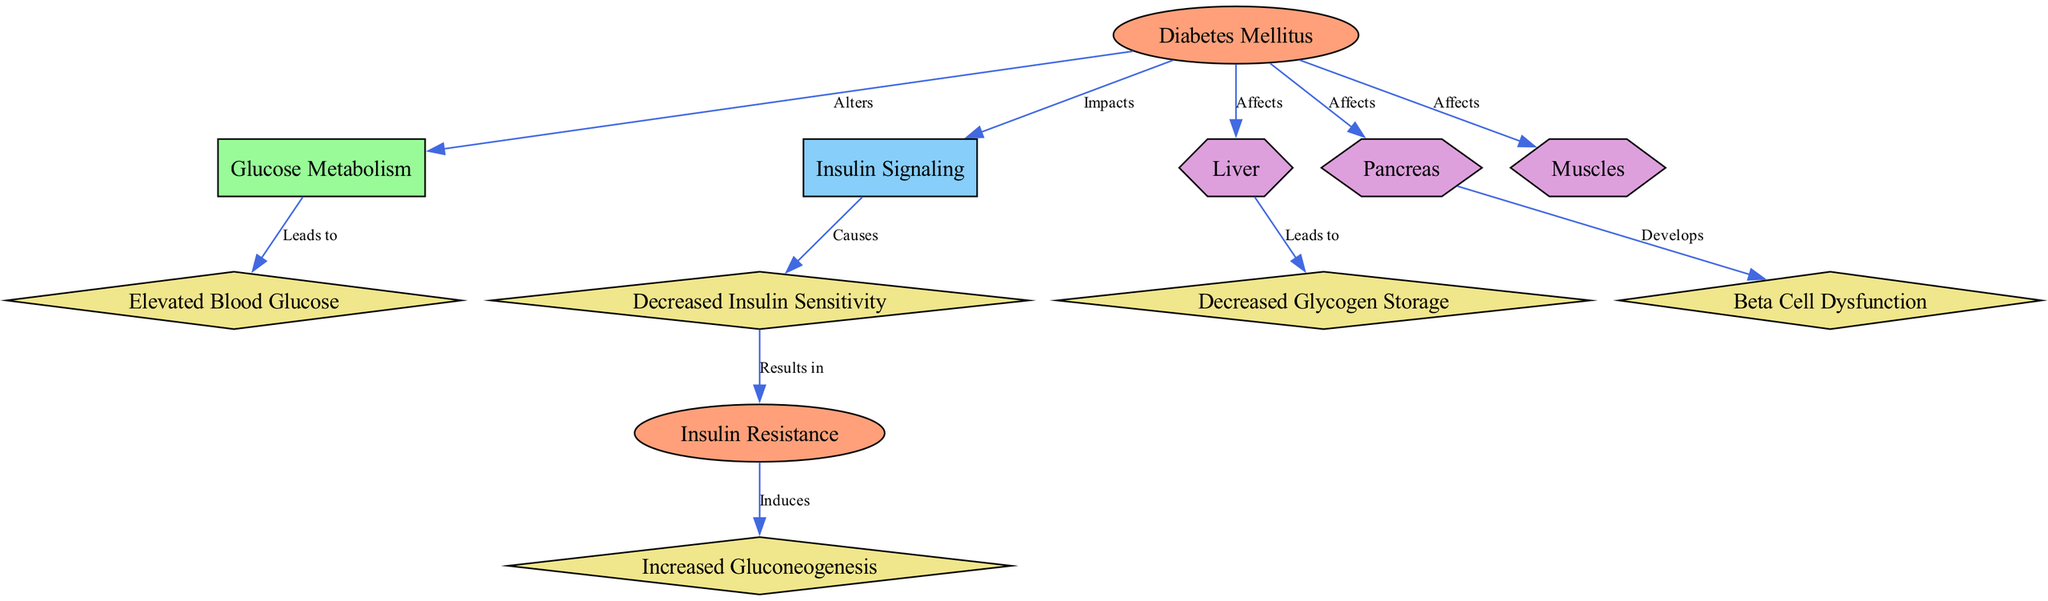What is the main condition depicted in the diagram? The main condition represented in the diagram is "Diabetes Mellitus," which is listed as a node in the diagram's initial position.
Answer: Diabetes Mellitus How many effects are shown in the diagram? By counting the nodes of type "effect," we find a total of five effects related to diabetes mellitus in the diagram.
Answer: 5 What type of pathway impacts insulin signaling in diabetes mellitus? The diagram indicates that "Diabetes Mellitus" impacts "Insulin Signaling," which is denoted by a directed edge labeled "Impacts."
Answer: Insulin Signaling Which organ develops beta cell dysfunction? The diagram indicates that "Pancreas" develops "Beta Cell Dysfunction," as shown by the directed edge labeled "Develops" connecting these two nodes.
Answer: Pancreas What leads to elevated blood glucose levels in diabetes? According to the edges in the diagram, "Glucose Metabolism" leads to "Elevated Blood Glucose," showing the cause-effect relationship in metabolic pathways.
Answer: Glucose Metabolism What results in insulin resistance? The flow in the diagram shows that "Decreased Insulin Sensitivity" results in "Insulin Resistance," indicating a progression from one condition to another in the context of diabetes mellitus.
Answer: Decreased Insulin Sensitivity What organ is affected by diabetes mellitus, impacting glycogen storage? The diagram illustrates that "Liver" is affected by "Diabetes Mellitus," which leads to "Decreased Glycogen Storage," indicating how this organ's function is altered in diabetes.
Answer: Liver Which metabolic effect is induced by insulin resistance? The diagram depicts that "Insulin Resistance" induces "Increased Gluconeogenesis," showing the sequelae of resistance on metabolic processes.
Answer: Increased Gluconeogenesis How does diabetes mellitus affect muscle tissue? The diagram specifies that "Diabetes Mellitus" affects "Muscles," although no specific effect related to muscles is detailed, the connection indicates the impact on this organ.
Answer: Muscles 